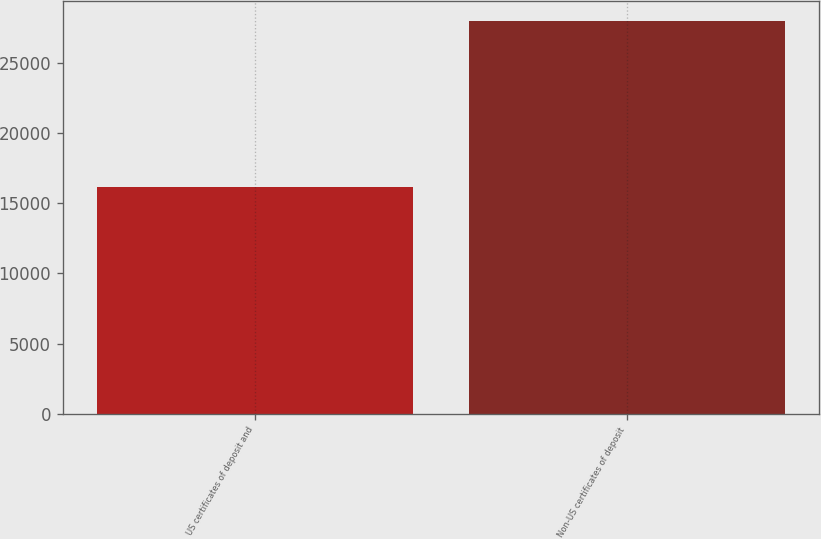Convert chart. <chart><loc_0><loc_0><loc_500><loc_500><bar_chart><fcel>US certificates of deposit and<fcel>Non-US certificates of deposit<nl><fcel>16140<fcel>27995<nl></chart> 